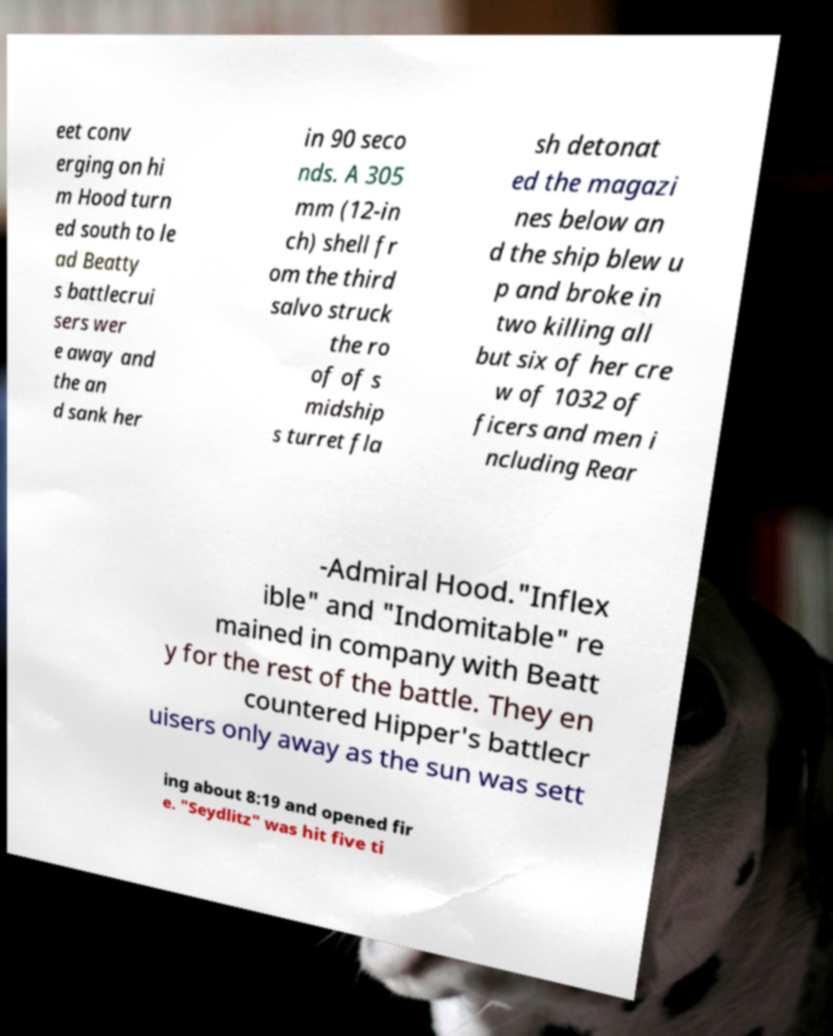Can you accurately transcribe the text from the provided image for me? eet conv erging on hi m Hood turn ed south to le ad Beatty s battlecrui sers wer e away and the an d sank her in 90 seco nds. A 305 mm (12-in ch) shell fr om the third salvo struck the ro of of s midship s turret fla sh detonat ed the magazi nes below an d the ship blew u p and broke in two killing all but six of her cre w of 1032 of ficers and men i ncluding Rear -Admiral Hood."Inflex ible" and "Indomitable" re mained in company with Beatt y for the rest of the battle. They en countered Hipper's battlecr uisers only away as the sun was sett ing about 8:19 and opened fir e. "Seydlitz" was hit five ti 